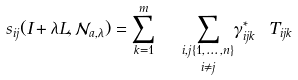Convert formula to latex. <formula><loc_0><loc_0><loc_500><loc_500>s _ { i j } ( I + \lambda L , \mathcal { N } _ { a , \lambda } ) = \sum ^ { m } _ { k = 1 } \ \ { \underset { i \not = j } { \underset { i , j \{ 1 , \dots , n \} } \sum } } \gamma ^ { * } _ { i j k } \ T _ { i j k }</formula> 